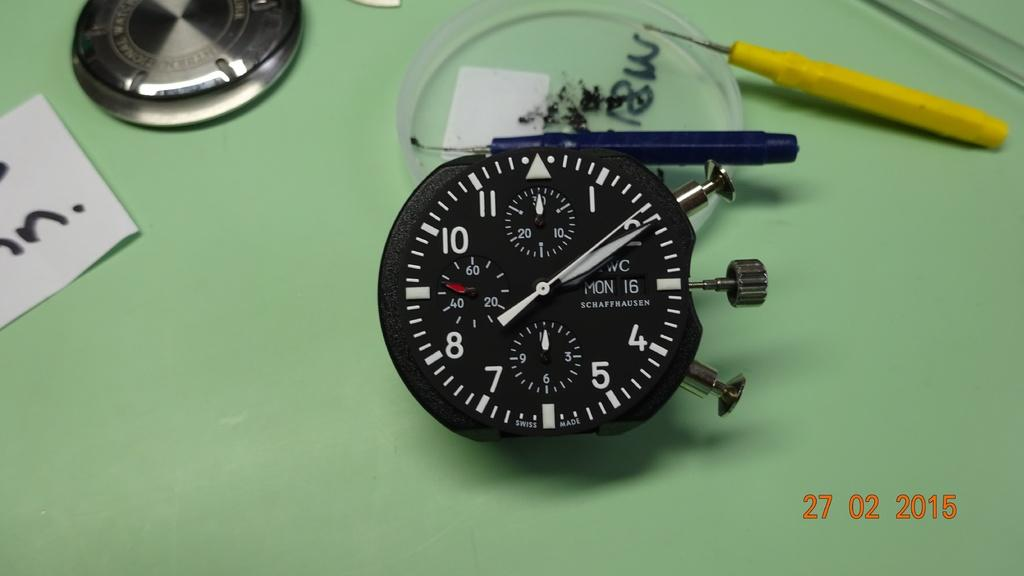<image>
Provide a brief description of the given image. Face of a watch that says the date is Monday 16th. 